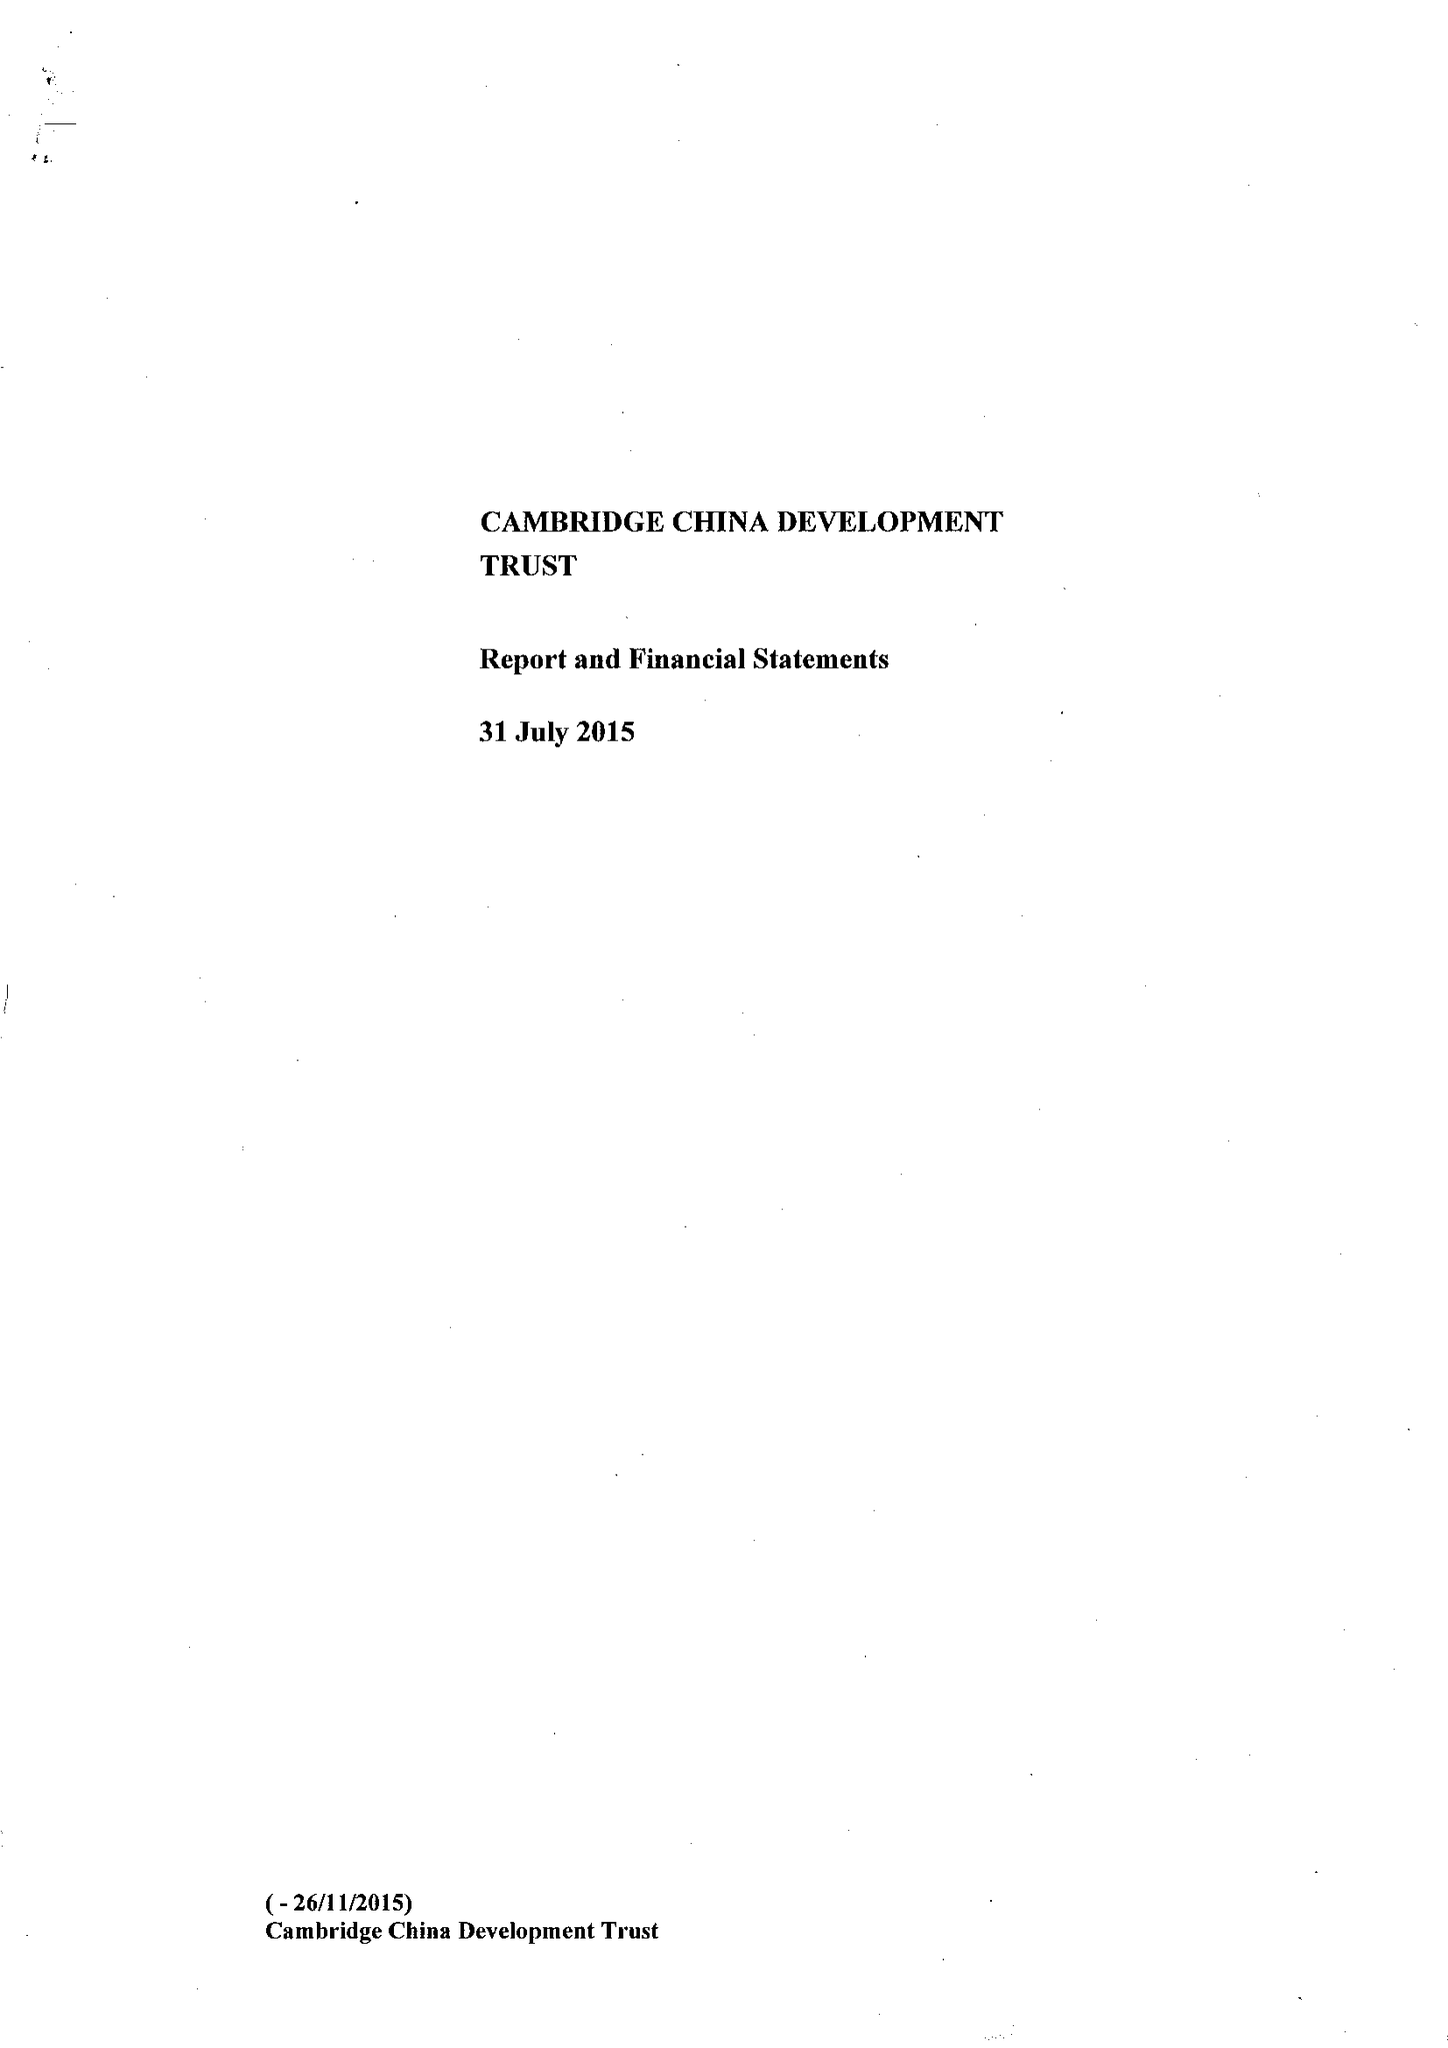What is the value for the charity_number?
Answer the question using a single word or phrase. 1111605 